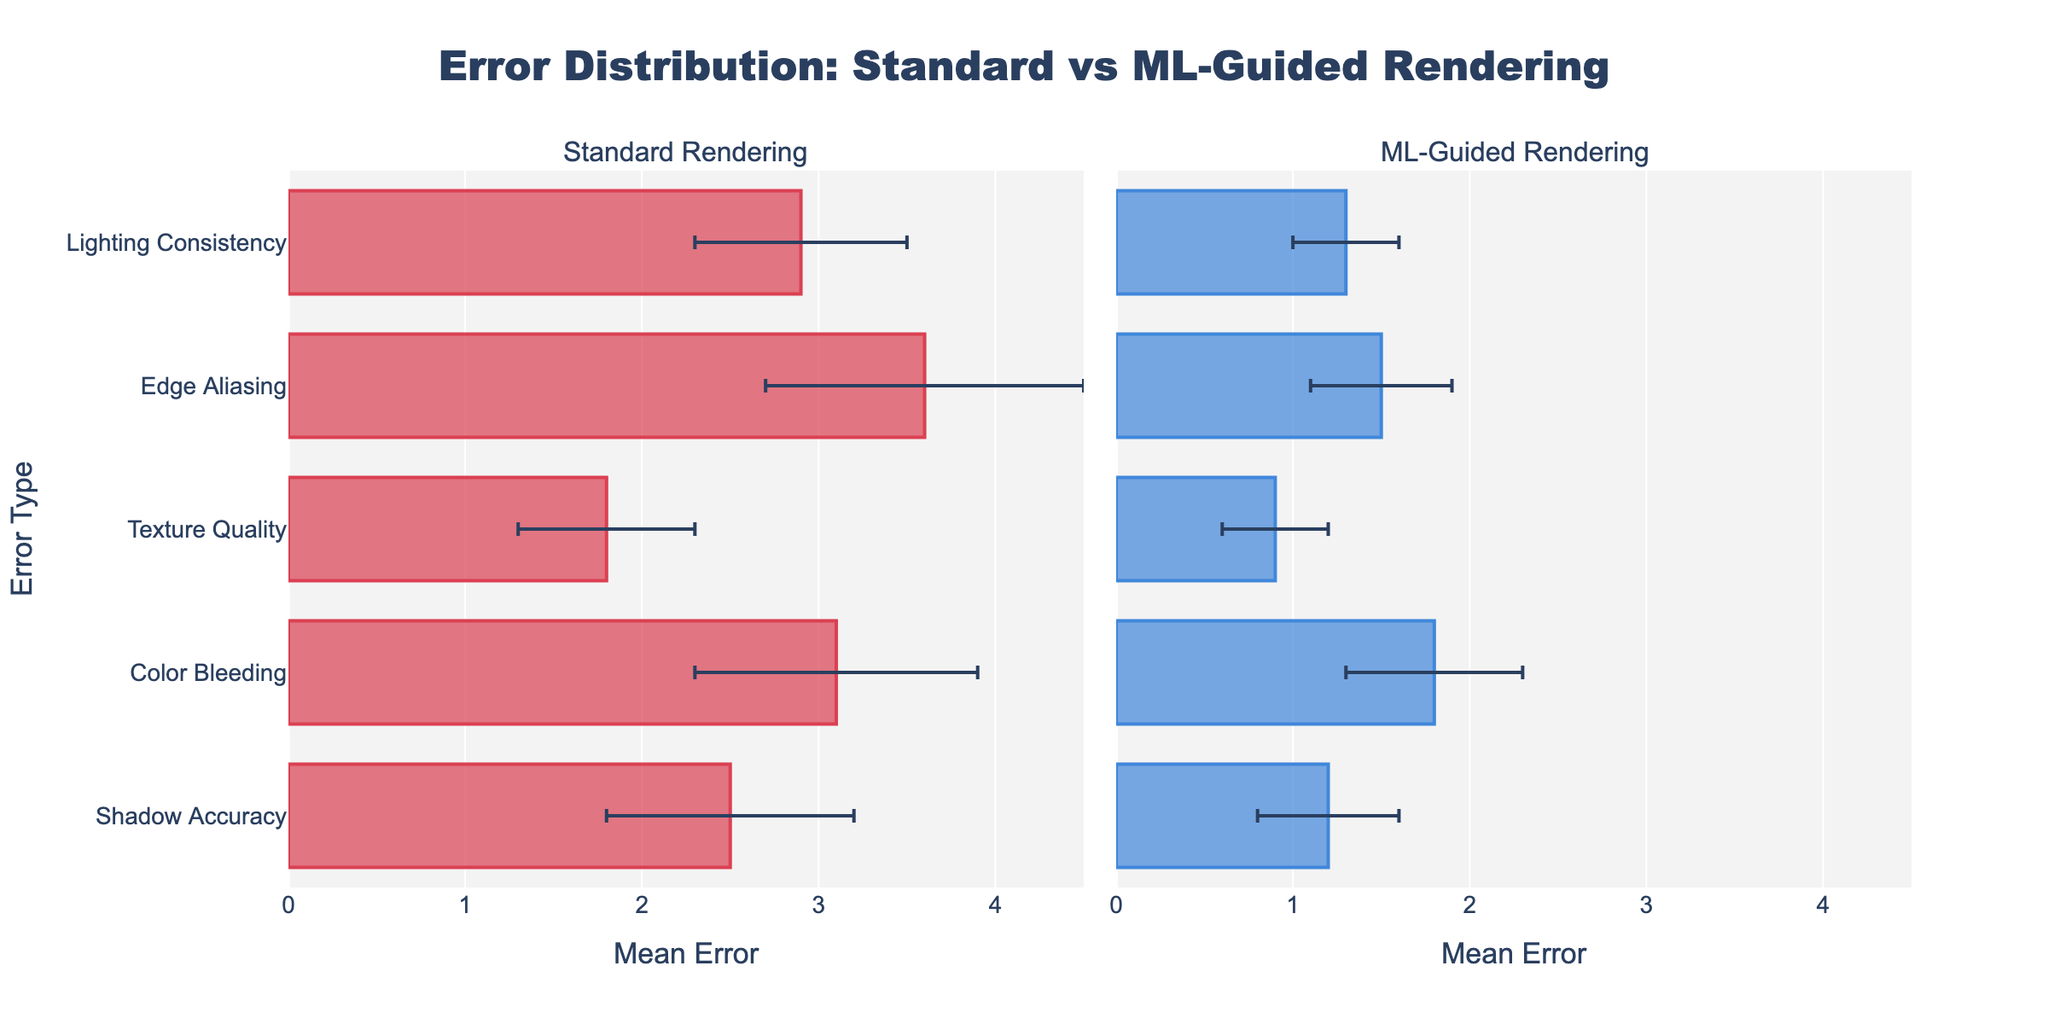How does the mean error for Shadow Accuracy compare between Standard Rendering and ML-Guided Rendering? To find the comparison, look at the length of the bars for Shadow Accuracy in both subplots. The bar in the Standard Rendering subplot extends to 2.5, while in the ML-Guided Rendering subplot, it extends to 1.2. Thus, Standard Rendering has a higher mean error for Shadow Accuracy.
Answer: Standard Rendering has a higher mean error Which error type shows the largest improvement when moving from Standard Rendering to ML-Guided Rendering? First, identify the mean errors in both render types for each error. Then, calculate the improvement as the difference in mean errors (Mean Error Standard - Mean Error ML-Guided). Calculate for each error:
Shadow Accuracy: 2.5 - 1.2 = 1.3
Color Bleeding: 3.1 - 1.8 = 1.3
Texture Quality: 1.8 - 0.9 = 0.9
Edge Aliasing: 3.6 - 1.5 = 2.1
Lighting Consistency: 2.9 - 1.3 = 1.6
The largest improvement is in "Edge Aliasing" with an improvement of 2.1.
Answer: Edge Aliasing What is the sum of mean errors for Standard Rendering across all error types? Add up the mean errors for all error types in Standard Rendering.
2.5 (Shadow Accuracy) + 3.1 (Color Bleeding) + 1.8 (Texture Quality) + 3.6 (Edge Aliasing) + 2.9 (Lighting Consistency) = 13.9
Answer: 13.9 Are the mean errors for Texture Quality for both rendering types closer to the left or right end of the x-axis? Examine the bar lengths for Texture Quality in both subplots. In Standard Rendering, the bar extends to 1.8, and in ML-Guided Rendering, it extends only to 0.9. Since both values are closer to 0 (left end), they are closer to the left end.
Answer: Closer to the left end Which error type has the smallest standard deviation in ML-Guided Rendering, and what is its value? Look at the error bars on top of the ML-Guided Rendering subplot for each error type and identify which is the smallest. Shadow Accuracy, Texture Quality, and Lighting Consistency all have standard deviations of 0.3, as indicated by the length of their error bars.
Answer: Texture Quality, 0.3 On which error type does ML-Guided Rendering perform nearly twice as well as Standard Rendering in terms of mean error? For nearly twice as well, we need to identify where the mean error in ML-Guided Rendering is approximately half of the Standard Rendering. Shadow Accuracy: 1.2 ~ 1/2 of 2.5, Color Bleeding: 1.8 is not close to 1/2 of 3.1, Texture Quality: 0.9 is 1/2 of 1.8, Edge Aliasing: 1.5 is less than 1/2 of 3.6, and Lighting Consistency: 1.3 is not close to 1/2 of 2.9. Thus, it’s "Texture Quality".
Answer: Texture Quality How much greater is the mean error for Color Bleeding in Standard Rendering compared to ML-Guided Rendering? Subtract the mean error of ML-Guided Rendering for Color Bleeding from the mean error of Standard Rendering for Color Bleeding. 3.1 (Standard) - 1.8 (ML-Guided) = 1.3
Answer: 1.3 What is the average of the mean errors for ML-Guided Rendering? Add up the mean errors for all error types in ML-Guided Rendering and divide by the number of error types. (1.2 + 1.8 + 0.9 + 1.5 + 1.3) / 5 = 6.7 / 5 = 1.34
Answer: 1.34 